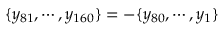Convert formula to latex. <formula><loc_0><loc_0><loc_500><loc_500>\{ y _ { 8 1 } , \cdots , y _ { 1 6 0 } \} = - \{ y _ { 8 0 } , \cdots , y _ { 1 } \}</formula> 